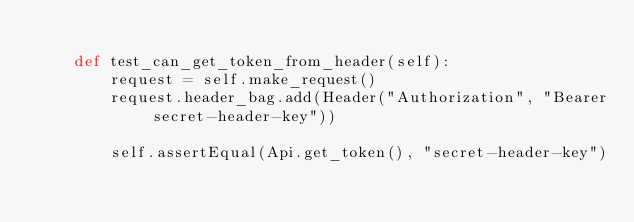Convert code to text. <code><loc_0><loc_0><loc_500><loc_500><_Python_>
    def test_can_get_token_from_header(self):
        request = self.make_request()
        request.header_bag.add(Header("Authorization", "Bearer secret-header-key"))

        self.assertEqual(Api.get_token(), "secret-header-key")
</code> 